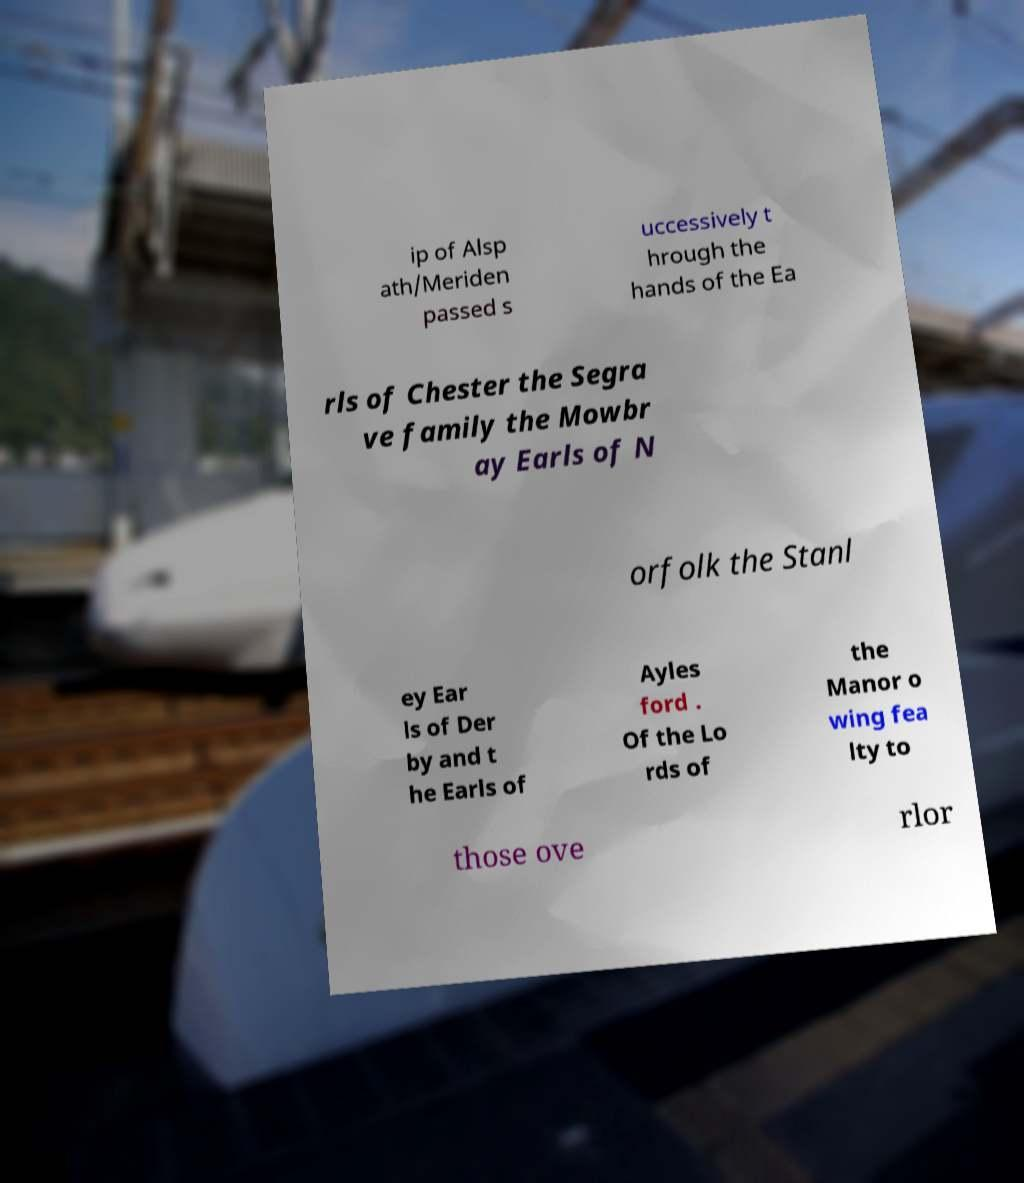What messages or text are displayed in this image? I need them in a readable, typed format. ip of Alsp ath/Meriden passed s uccessively t hrough the hands of the Ea rls of Chester the Segra ve family the Mowbr ay Earls of N orfolk the Stanl ey Ear ls of Der by and t he Earls of Ayles ford . Of the Lo rds of the Manor o wing fea lty to those ove rlor 